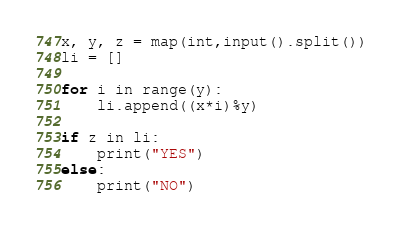<code> <loc_0><loc_0><loc_500><loc_500><_Python_>x, y, z = map(int,input().split())
li = []

for i in range(y):
    li.append((x*i)%y)

if z in li:
    print("YES")
else:
    print("NO")</code> 